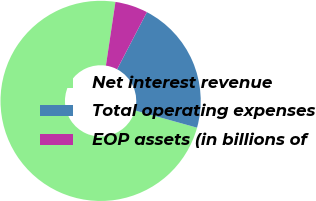Convert chart. <chart><loc_0><loc_0><loc_500><loc_500><pie_chart><fcel>Net interest revenue<fcel>Total operating expenses<fcel>EOP assets (in billions of<nl><fcel>73.05%<fcel>21.66%<fcel>5.28%<nl></chart> 